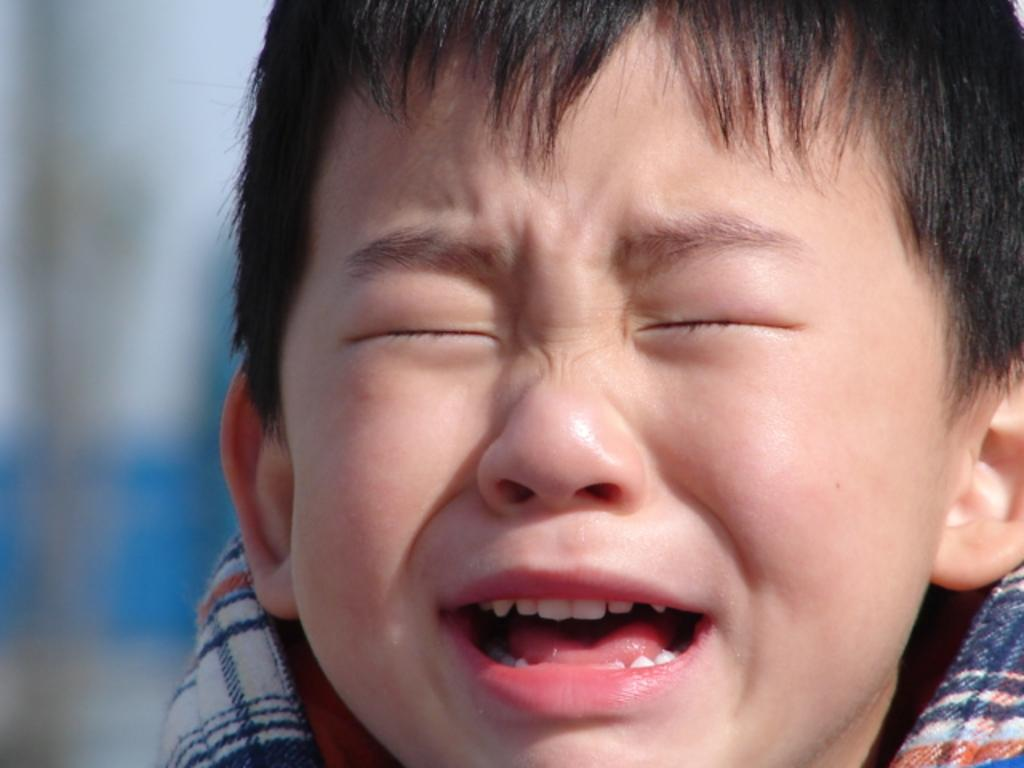What is the main subject of the image? The main subject of the image is a small kid. What is the kid doing in the image? The kid is crying in the image. What is the position of the kid's eyes? The kid has his eyes closed in the image. What type of operation is being performed on the kid in the image? There is no indication in the image that the kid is undergoing any operation. What is causing the air to be filled with the kid's tears in the image? There is no indication in the image that the kid's tears are causing the air to be filled with them. 